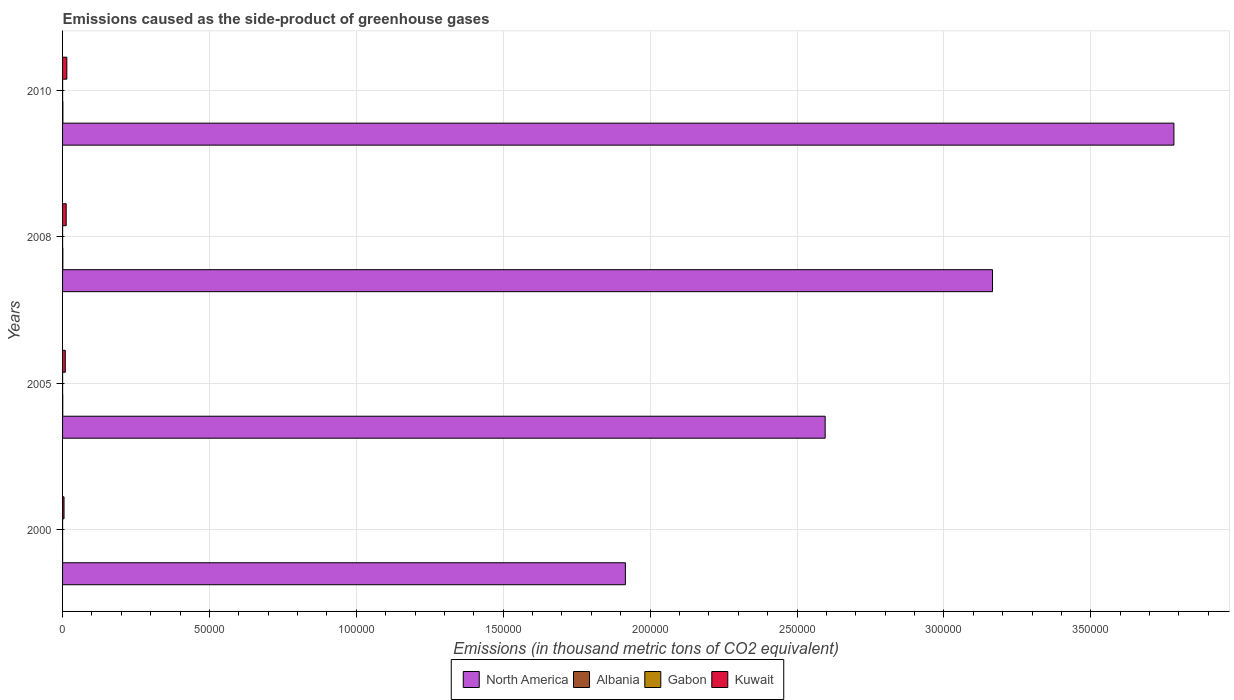Are the number of bars per tick equal to the number of legend labels?
Give a very brief answer. Yes. How many bars are there on the 1st tick from the top?
Your response must be concise. 4. How many bars are there on the 1st tick from the bottom?
Keep it short and to the point. 4. What is the label of the 1st group of bars from the top?
Provide a short and direct response. 2010. What is the emissions caused as the side-product of greenhouse gases in Kuwait in 2005?
Provide a succinct answer. 925.6. Across all years, what is the maximum emissions caused as the side-product of greenhouse gases in Gabon?
Your response must be concise. 14. Across all years, what is the minimum emissions caused as the side-product of greenhouse gases in Kuwait?
Make the answer very short. 498.2. What is the total emissions caused as the side-product of greenhouse gases in Kuwait in the graph?
Give a very brief answer. 4110.2. What is the difference between the emissions caused as the side-product of greenhouse gases in North America in 2000 and that in 2005?
Keep it short and to the point. -6.80e+04. What is the difference between the emissions caused as the side-product of greenhouse gases in Albania in 2010 and the emissions caused as the side-product of greenhouse gases in North America in 2008?
Provide a succinct answer. -3.16e+05. What is the average emissions caused as the side-product of greenhouse gases in North America per year?
Your answer should be compact. 2.87e+05. In the year 2010, what is the difference between the emissions caused as the side-product of greenhouse gases in Kuwait and emissions caused as the side-product of greenhouse gases in Albania?
Provide a succinct answer. 1346. What is the ratio of the emissions caused as the side-product of greenhouse gases in Kuwait in 2000 to that in 2010?
Provide a succinct answer. 0.34. Is the difference between the emissions caused as the side-product of greenhouse gases in Kuwait in 2005 and 2008 greater than the difference between the emissions caused as the side-product of greenhouse gases in Albania in 2005 and 2008?
Offer a very short reply. No. What is the difference between the highest and the second highest emissions caused as the side-product of greenhouse gases in Gabon?
Offer a very short reply. 2.2. In how many years, is the emissions caused as the side-product of greenhouse gases in Gabon greater than the average emissions caused as the side-product of greenhouse gases in Gabon taken over all years?
Ensure brevity in your answer.  2. What does the 3rd bar from the bottom in 2010 represents?
Provide a succinct answer. Gabon. What is the difference between two consecutive major ticks on the X-axis?
Keep it short and to the point. 5.00e+04. Where does the legend appear in the graph?
Your answer should be compact. Bottom center. How many legend labels are there?
Ensure brevity in your answer.  4. What is the title of the graph?
Offer a terse response. Emissions caused as the side-product of greenhouse gases. What is the label or title of the X-axis?
Provide a short and direct response. Emissions (in thousand metric tons of CO2 equivalent). What is the Emissions (in thousand metric tons of CO2 equivalent) of North America in 2000?
Provide a succinct answer. 1.92e+05. What is the Emissions (in thousand metric tons of CO2 equivalent) in Gabon in 2000?
Make the answer very short. 2.9. What is the Emissions (in thousand metric tons of CO2 equivalent) in Kuwait in 2000?
Your answer should be very brief. 498.2. What is the Emissions (in thousand metric tons of CO2 equivalent) of North America in 2005?
Ensure brevity in your answer.  2.60e+05. What is the Emissions (in thousand metric tons of CO2 equivalent) of Albania in 2005?
Keep it short and to the point. 61.8. What is the Emissions (in thousand metric tons of CO2 equivalent) in Gabon in 2005?
Your answer should be very brief. 8.4. What is the Emissions (in thousand metric tons of CO2 equivalent) in Kuwait in 2005?
Ensure brevity in your answer.  925.6. What is the Emissions (in thousand metric tons of CO2 equivalent) of North America in 2008?
Offer a very short reply. 3.17e+05. What is the Emissions (in thousand metric tons of CO2 equivalent) of Albania in 2008?
Ensure brevity in your answer.  86.9. What is the Emissions (in thousand metric tons of CO2 equivalent) in Kuwait in 2008?
Your answer should be compact. 1235.4. What is the Emissions (in thousand metric tons of CO2 equivalent) of North America in 2010?
Your answer should be compact. 3.78e+05. What is the Emissions (in thousand metric tons of CO2 equivalent) in Albania in 2010?
Your response must be concise. 105. What is the Emissions (in thousand metric tons of CO2 equivalent) in Gabon in 2010?
Make the answer very short. 14. What is the Emissions (in thousand metric tons of CO2 equivalent) in Kuwait in 2010?
Offer a terse response. 1451. Across all years, what is the maximum Emissions (in thousand metric tons of CO2 equivalent) in North America?
Ensure brevity in your answer.  3.78e+05. Across all years, what is the maximum Emissions (in thousand metric tons of CO2 equivalent) in Albania?
Offer a terse response. 105. Across all years, what is the maximum Emissions (in thousand metric tons of CO2 equivalent) of Gabon?
Give a very brief answer. 14. Across all years, what is the maximum Emissions (in thousand metric tons of CO2 equivalent) of Kuwait?
Your answer should be compact. 1451. Across all years, what is the minimum Emissions (in thousand metric tons of CO2 equivalent) in North America?
Your response must be concise. 1.92e+05. Across all years, what is the minimum Emissions (in thousand metric tons of CO2 equivalent) in Gabon?
Your response must be concise. 2.9. Across all years, what is the minimum Emissions (in thousand metric tons of CO2 equivalent) in Kuwait?
Your response must be concise. 498.2. What is the total Emissions (in thousand metric tons of CO2 equivalent) in North America in the graph?
Your answer should be compact. 1.15e+06. What is the total Emissions (in thousand metric tons of CO2 equivalent) in Albania in the graph?
Offer a very short reply. 269.2. What is the total Emissions (in thousand metric tons of CO2 equivalent) of Gabon in the graph?
Provide a short and direct response. 37.1. What is the total Emissions (in thousand metric tons of CO2 equivalent) in Kuwait in the graph?
Make the answer very short. 4110.2. What is the difference between the Emissions (in thousand metric tons of CO2 equivalent) of North America in 2000 and that in 2005?
Offer a terse response. -6.80e+04. What is the difference between the Emissions (in thousand metric tons of CO2 equivalent) of Albania in 2000 and that in 2005?
Your answer should be very brief. -46.3. What is the difference between the Emissions (in thousand metric tons of CO2 equivalent) in Kuwait in 2000 and that in 2005?
Give a very brief answer. -427.4. What is the difference between the Emissions (in thousand metric tons of CO2 equivalent) in North America in 2000 and that in 2008?
Ensure brevity in your answer.  -1.25e+05. What is the difference between the Emissions (in thousand metric tons of CO2 equivalent) in Albania in 2000 and that in 2008?
Your answer should be very brief. -71.4. What is the difference between the Emissions (in thousand metric tons of CO2 equivalent) of Kuwait in 2000 and that in 2008?
Offer a terse response. -737.2. What is the difference between the Emissions (in thousand metric tons of CO2 equivalent) in North America in 2000 and that in 2010?
Your response must be concise. -1.87e+05. What is the difference between the Emissions (in thousand metric tons of CO2 equivalent) of Albania in 2000 and that in 2010?
Make the answer very short. -89.5. What is the difference between the Emissions (in thousand metric tons of CO2 equivalent) of Gabon in 2000 and that in 2010?
Your response must be concise. -11.1. What is the difference between the Emissions (in thousand metric tons of CO2 equivalent) in Kuwait in 2000 and that in 2010?
Offer a very short reply. -952.8. What is the difference between the Emissions (in thousand metric tons of CO2 equivalent) of North America in 2005 and that in 2008?
Your answer should be compact. -5.70e+04. What is the difference between the Emissions (in thousand metric tons of CO2 equivalent) of Albania in 2005 and that in 2008?
Ensure brevity in your answer.  -25.1. What is the difference between the Emissions (in thousand metric tons of CO2 equivalent) of Kuwait in 2005 and that in 2008?
Ensure brevity in your answer.  -309.8. What is the difference between the Emissions (in thousand metric tons of CO2 equivalent) in North America in 2005 and that in 2010?
Keep it short and to the point. -1.19e+05. What is the difference between the Emissions (in thousand metric tons of CO2 equivalent) in Albania in 2005 and that in 2010?
Offer a terse response. -43.2. What is the difference between the Emissions (in thousand metric tons of CO2 equivalent) in Kuwait in 2005 and that in 2010?
Make the answer very short. -525.4. What is the difference between the Emissions (in thousand metric tons of CO2 equivalent) in North America in 2008 and that in 2010?
Offer a very short reply. -6.17e+04. What is the difference between the Emissions (in thousand metric tons of CO2 equivalent) in Albania in 2008 and that in 2010?
Keep it short and to the point. -18.1. What is the difference between the Emissions (in thousand metric tons of CO2 equivalent) of Gabon in 2008 and that in 2010?
Your response must be concise. -2.2. What is the difference between the Emissions (in thousand metric tons of CO2 equivalent) in Kuwait in 2008 and that in 2010?
Give a very brief answer. -215.6. What is the difference between the Emissions (in thousand metric tons of CO2 equivalent) in North America in 2000 and the Emissions (in thousand metric tons of CO2 equivalent) in Albania in 2005?
Offer a very short reply. 1.92e+05. What is the difference between the Emissions (in thousand metric tons of CO2 equivalent) in North America in 2000 and the Emissions (in thousand metric tons of CO2 equivalent) in Gabon in 2005?
Keep it short and to the point. 1.92e+05. What is the difference between the Emissions (in thousand metric tons of CO2 equivalent) in North America in 2000 and the Emissions (in thousand metric tons of CO2 equivalent) in Kuwait in 2005?
Ensure brevity in your answer.  1.91e+05. What is the difference between the Emissions (in thousand metric tons of CO2 equivalent) in Albania in 2000 and the Emissions (in thousand metric tons of CO2 equivalent) in Kuwait in 2005?
Keep it short and to the point. -910.1. What is the difference between the Emissions (in thousand metric tons of CO2 equivalent) of Gabon in 2000 and the Emissions (in thousand metric tons of CO2 equivalent) of Kuwait in 2005?
Offer a very short reply. -922.7. What is the difference between the Emissions (in thousand metric tons of CO2 equivalent) of North America in 2000 and the Emissions (in thousand metric tons of CO2 equivalent) of Albania in 2008?
Your response must be concise. 1.91e+05. What is the difference between the Emissions (in thousand metric tons of CO2 equivalent) in North America in 2000 and the Emissions (in thousand metric tons of CO2 equivalent) in Gabon in 2008?
Keep it short and to the point. 1.92e+05. What is the difference between the Emissions (in thousand metric tons of CO2 equivalent) of North America in 2000 and the Emissions (in thousand metric tons of CO2 equivalent) of Kuwait in 2008?
Your answer should be very brief. 1.90e+05. What is the difference between the Emissions (in thousand metric tons of CO2 equivalent) in Albania in 2000 and the Emissions (in thousand metric tons of CO2 equivalent) in Kuwait in 2008?
Offer a very short reply. -1219.9. What is the difference between the Emissions (in thousand metric tons of CO2 equivalent) of Gabon in 2000 and the Emissions (in thousand metric tons of CO2 equivalent) of Kuwait in 2008?
Your answer should be compact. -1232.5. What is the difference between the Emissions (in thousand metric tons of CO2 equivalent) of North America in 2000 and the Emissions (in thousand metric tons of CO2 equivalent) of Albania in 2010?
Provide a short and direct response. 1.91e+05. What is the difference between the Emissions (in thousand metric tons of CO2 equivalent) of North America in 2000 and the Emissions (in thousand metric tons of CO2 equivalent) of Gabon in 2010?
Your answer should be compact. 1.92e+05. What is the difference between the Emissions (in thousand metric tons of CO2 equivalent) of North America in 2000 and the Emissions (in thousand metric tons of CO2 equivalent) of Kuwait in 2010?
Ensure brevity in your answer.  1.90e+05. What is the difference between the Emissions (in thousand metric tons of CO2 equivalent) of Albania in 2000 and the Emissions (in thousand metric tons of CO2 equivalent) of Kuwait in 2010?
Your answer should be compact. -1435.5. What is the difference between the Emissions (in thousand metric tons of CO2 equivalent) in Gabon in 2000 and the Emissions (in thousand metric tons of CO2 equivalent) in Kuwait in 2010?
Keep it short and to the point. -1448.1. What is the difference between the Emissions (in thousand metric tons of CO2 equivalent) in North America in 2005 and the Emissions (in thousand metric tons of CO2 equivalent) in Albania in 2008?
Your answer should be compact. 2.59e+05. What is the difference between the Emissions (in thousand metric tons of CO2 equivalent) in North America in 2005 and the Emissions (in thousand metric tons of CO2 equivalent) in Gabon in 2008?
Give a very brief answer. 2.60e+05. What is the difference between the Emissions (in thousand metric tons of CO2 equivalent) of North America in 2005 and the Emissions (in thousand metric tons of CO2 equivalent) of Kuwait in 2008?
Your answer should be very brief. 2.58e+05. What is the difference between the Emissions (in thousand metric tons of CO2 equivalent) in Albania in 2005 and the Emissions (in thousand metric tons of CO2 equivalent) in Kuwait in 2008?
Your answer should be compact. -1173.6. What is the difference between the Emissions (in thousand metric tons of CO2 equivalent) of Gabon in 2005 and the Emissions (in thousand metric tons of CO2 equivalent) of Kuwait in 2008?
Make the answer very short. -1227. What is the difference between the Emissions (in thousand metric tons of CO2 equivalent) in North America in 2005 and the Emissions (in thousand metric tons of CO2 equivalent) in Albania in 2010?
Give a very brief answer. 2.59e+05. What is the difference between the Emissions (in thousand metric tons of CO2 equivalent) of North America in 2005 and the Emissions (in thousand metric tons of CO2 equivalent) of Gabon in 2010?
Your answer should be compact. 2.60e+05. What is the difference between the Emissions (in thousand metric tons of CO2 equivalent) of North America in 2005 and the Emissions (in thousand metric tons of CO2 equivalent) of Kuwait in 2010?
Provide a succinct answer. 2.58e+05. What is the difference between the Emissions (in thousand metric tons of CO2 equivalent) in Albania in 2005 and the Emissions (in thousand metric tons of CO2 equivalent) in Gabon in 2010?
Provide a short and direct response. 47.8. What is the difference between the Emissions (in thousand metric tons of CO2 equivalent) of Albania in 2005 and the Emissions (in thousand metric tons of CO2 equivalent) of Kuwait in 2010?
Offer a very short reply. -1389.2. What is the difference between the Emissions (in thousand metric tons of CO2 equivalent) in Gabon in 2005 and the Emissions (in thousand metric tons of CO2 equivalent) in Kuwait in 2010?
Your answer should be very brief. -1442.6. What is the difference between the Emissions (in thousand metric tons of CO2 equivalent) in North America in 2008 and the Emissions (in thousand metric tons of CO2 equivalent) in Albania in 2010?
Provide a succinct answer. 3.16e+05. What is the difference between the Emissions (in thousand metric tons of CO2 equivalent) in North America in 2008 and the Emissions (in thousand metric tons of CO2 equivalent) in Gabon in 2010?
Provide a succinct answer. 3.17e+05. What is the difference between the Emissions (in thousand metric tons of CO2 equivalent) of North America in 2008 and the Emissions (in thousand metric tons of CO2 equivalent) of Kuwait in 2010?
Provide a succinct answer. 3.15e+05. What is the difference between the Emissions (in thousand metric tons of CO2 equivalent) of Albania in 2008 and the Emissions (in thousand metric tons of CO2 equivalent) of Gabon in 2010?
Make the answer very short. 72.9. What is the difference between the Emissions (in thousand metric tons of CO2 equivalent) in Albania in 2008 and the Emissions (in thousand metric tons of CO2 equivalent) in Kuwait in 2010?
Give a very brief answer. -1364.1. What is the difference between the Emissions (in thousand metric tons of CO2 equivalent) of Gabon in 2008 and the Emissions (in thousand metric tons of CO2 equivalent) of Kuwait in 2010?
Your answer should be compact. -1439.2. What is the average Emissions (in thousand metric tons of CO2 equivalent) of North America per year?
Your response must be concise. 2.87e+05. What is the average Emissions (in thousand metric tons of CO2 equivalent) of Albania per year?
Offer a terse response. 67.3. What is the average Emissions (in thousand metric tons of CO2 equivalent) in Gabon per year?
Make the answer very short. 9.28. What is the average Emissions (in thousand metric tons of CO2 equivalent) in Kuwait per year?
Offer a very short reply. 1027.55. In the year 2000, what is the difference between the Emissions (in thousand metric tons of CO2 equivalent) of North America and Emissions (in thousand metric tons of CO2 equivalent) of Albania?
Provide a short and direct response. 1.92e+05. In the year 2000, what is the difference between the Emissions (in thousand metric tons of CO2 equivalent) in North America and Emissions (in thousand metric tons of CO2 equivalent) in Gabon?
Offer a very short reply. 1.92e+05. In the year 2000, what is the difference between the Emissions (in thousand metric tons of CO2 equivalent) of North America and Emissions (in thousand metric tons of CO2 equivalent) of Kuwait?
Provide a short and direct response. 1.91e+05. In the year 2000, what is the difference between the Emissions (in thousand metric tons of CO2 equivalent) of Albania and Emissions (in thousand metric tons of CO2 equivalent) of Kuwait?
Give a very brief answer. -482.7. In the year 2000, what is the difference between the Emissions (in thousand metric tons of CO2 equivalent) of Gabon and Emissions (in thousand metric tons of CO2 equivalent) of Kuwait?
Your response must be concise. -495.3. In the year 2005, what is the difference between the Emissions (in thousand metric tons of CO2 equivalent) in North America and Emissions (in thousand metric tons of CO2 equivalent) in Albania?
Provide a short and direct response. 2.60e+05. In the year 2005, what is the difference between the Emissions (in thousand metric tons of CO2 equivalent) of North America and Emissions (in thousand metric tons of CO2 equivalent) of Gabon?
Make the answer very short. 2.60e+05. In the year 2005, what is the difference between the Emissions (in thousand metric tons of CO2 equivalent) of North America and Emissions (in thousand metric tons of CO2 equivalent) of Kuwait?
Provide a short and direct response. 2.59e+05. In the year 2005, what is the difference between the Emissions (in thousand metric tons of CO2 equivalent) of Albania and Emissions (in thousand metric tons of CO2 equivalent) of Gabon?
Your answer should be compact. 53.4. In the year 2005, what is the difference between the Emissions (in thousand metric tons of CO2 equivalent) of Albania and Emissions (in thousand metric tons of CO2 equivalent) of Kuwait?
Offer a very short reply. -863.8. In the year 2005, what is the difference between the Emissions (in thousand metric tons of CO2 equivalent) in Gabon and Emissions (in thousand metric tons of CO2 equivalent) in Kuwait?
Your response must be concise. -917.2. In the year 2008, what is the difference between the Emissions (in thousand metric tons of CO2 equivalent) in North America and Emissions (in thousand metric tons of CO2 equivalent) in Albania?
Offer a very short reply. 3.16e+05. In the year 2008, what is the difference between the Emissions (in thousand metric tons of CO2 equivalent) of North America and Emissions (in thousand metric tons of CO2 equivalent) of Gabon?
Your answer should be compact. 3.17e+05. In the year 2008, what is the difference between the Emissions (in thousand metric tons of CO2 equivalent) of North America and Emissions (in thousand metric tons of CO2 equivalent) of Kuwait?
Your response must be concise. 3.15e+05. In the year 2008, what is the difference between the Emissions (in thousand metric tons of CO2 equivalent) in Albania and Emissions (in thousand metric tons of CO2 equivalent) in Gabon?
Offer a terse response. 75.1. In the year 2008, what is the difference between the Emissions (in thousand metric tons of CO2 equivalent) of Albania and Emissions (in thousand metric tons of CO2 equivalent) of Kuwait?
Make the answer very short. -1148.5. In the year 2008, what is the difference between the Emissions (in thousand metric tons of CO2 equivalent) of Gabon and Emissions (in thousand metric tons of CO2 equivalent) of Kuwait?
Provide a short and direct response. -1223.6. In the year 2010, what is the difference between the Emissions (in thousand metric tons of CO2 equivalent) in North America and Emissions (in thousand metric tons of CO2 equivalent) in Albania?
Your answer should be compact. 3.78e+05. In the year 2010, what is the difference between the Emissions (in thousand metric tons of CO2 equivalent) in North America and Emissions (in thousand metric tons of CO2 equivalent) in Gabon?
Ensure brevity in your answer.  3.78e+05. In the year 2010, what is the difference between the Emissions (in thousand metric tons of CO2 equivalent) in North America and Emissions (in thousand metric tons of CO2 equivalent) in Kuwait?
Give a very brief answer. 3.77e+05. In the year 2010, what is the difference between the Emissions (in thousand metric tons of CO2 equivalent) in Albania and Emissions (in thousand metric tons of CO2 equivalent) in Gabon?
Your response must be concise. 91. In the year 2010, what is the difference between the Emissions (in thousand metric tons of CO2 equivalent) in Albania and Emissions (in thousand metric tons of CO2 equivalent) in Kuwait?
Make the answer very short. -1346. In the year 2010, what is the difference between the Emissions (in thousand metric tons of CO2 equivalent) in Gabon and Emissions (in thousand metric tons of CO2 equivalent) in Kuwait?
Offer a terse response. -1437. What is the ratio of the Emissions (in thousand metric tons of CO2 equivalent) of North America in 2000 to that in 2005?
Offer a very short reply. 0.74. What is the ratio of the Emissions (in thousand metric tons of CO2 equivalent) in Albania in 2000 to that in 2005?
Give a very brief answer. 0.25. What is the ratio of the Emissions (in thousand metric tons of CO2 equivalent) of Gabon in 2000 to that in 2005?
Your answer should be compact. 0.35. What is the ratio of the Emissions (in thousand metric tons of CO2 equivalent) of Kuwait in 2000 to that in 2005?
Your response must be concise. 0.54. What is the ratio of the Emissions (in thousand metric tons of CO2 equivalent) of North America in 2000 to that in 2008?
Keep it short and to the point. 0.61. What is the ratio of the Emissions (in thousand metric tons of CO2 equivalent) in Albania in 2000 to that in 2008?
Give a very brief answer. 0.18. What is the ratio of the Emissions (in thousand metric tons of CO2 equivalent) in Gabon in 2000 to that in 2008?
Provide a succinct answer. 0.25. What is the ratio of the Emissions (in thousand metric tons of CO2 equivalent) in Kuwait in 2000 to that in 2008?
Offer a terse response. 0.4. What is the ratio of the Emissions (in thousand metric tons of CO2 equivalent) in North America in 2000 to that in 2010?
Make the answer very short. 0.51. What is the ratio of the Emissions (in thousand metric tons of CO2 equivalent) in Albania in 2000 to that in 2010?
Give a very brief answer. 0.15. What is the ratio of the Emissions (in thousand metric tons of CO2 equivalent) in Gabon in 2000 to that in 2010?
Make the answer very short. 0.21. What is the ratio of the Emissions (in thousand metric tons of CO2 equivalent) in Kuwait in 2000 to that in 2010?
Ensure brevity in your answer.  0.34. What is the ratio of the Emissions (in thousand metric tons of CO2 equivalent) of North America in 2005 to that in 2008?
Make the answer very short. 0.82. What is the ratio of the Emissions (in thousand metric tons of CO2 equivalent) of Albania in 2005 to that in 2008?
Provide a short and direct response. 0.71. What is the ratio of the Emissions (in thousand metric tons of CO2 equivalent) of Gabon in 2005 to that in 2008?
Offer a very short reply. 0.71. What is the ratio of the Emissions (in thousand metric tons of CO2 equivalent) of Kuwait in 2005 to that in 2008?
Keep it short and to the point. 0.75. What is the ratio of the Emissions (in thousand metric tons of CO2 equivalent) of North America in 2005 to that in 2010?
Give a very brief answer. 0.69. What is the ratio of the Emissions (in thousand metric tons of CO2 equivalent) of Albania in 2005 to that in 2010?
Keep it short and to the point. 0.59. What is the ratio of the Emissions (in thousand metric tons of CO2 equivalent) of Kuwait in 2005 to that in 2010?
Offer a terse response. 0.64. What is the ratio of the Emissions (in thousand metric tons of CO2 equivalent) in North America in 2008 to that in 2010?
Ensure brevity in your answer.  0.84. What is the ratio of the Emissions (in thousand metric tons of CO2 equivalent) in Albania in 2008 to that in 2010?
Keep it short and to the point. 0.83. What is the ratio of the Emissions (in thousand metric tons of CO2 equivalent) in Gabon in 2008 to that in 2010?
Offer a terse response. 0.84. What is the ratio of the Emissions (in thousand metric tons of CO2 equivalent) of Kuwait in 2008 to that in 2010?
Your answer should be very brief. 0.85. What is the difference between the highest and the second highest Emissions (in thousand metric tons of CO2 equivalent) in North America?
Keep it short and to the point. 6.17e+04. What is the difference between the highest and the second highest Emissions (in thousand metric tons of CO2 equivalent) in Albania?
Your response must be concise. 18.1. What is the difference between the highest and the second highest Emissions (in thousand metric tons of CO2 equivalent) of Gabon?
Ensure brevity in your answer.  2.2. What is the difference between the highest and the second highest Emissions (in thousand metric tons of CO2 equivalent) in Kuwait?
Ensure brevity in your answer.  215.6. What is the difference between the highest and the lowest Emissions (in thousand metric tons of CO2 equivalent) of North America?
Provide a short and direct response. 1.87e+05. What is the difference between the highest and the lowest Emissions (in thousand metric tons of CO2 equivalent) of Albania?
Your response must be concise. 89.5. What is the difference between the highest and the lowest Emissions (in thousand metric tons of CO2 equivalent) in Gabon?
Give a very brief answer. 11.1. What is the difference between the highest and the lowest Emissions (in thousand metric tons of CO2 equivalent) in Kuwait?
Provide a succinct answer. 952.8. 